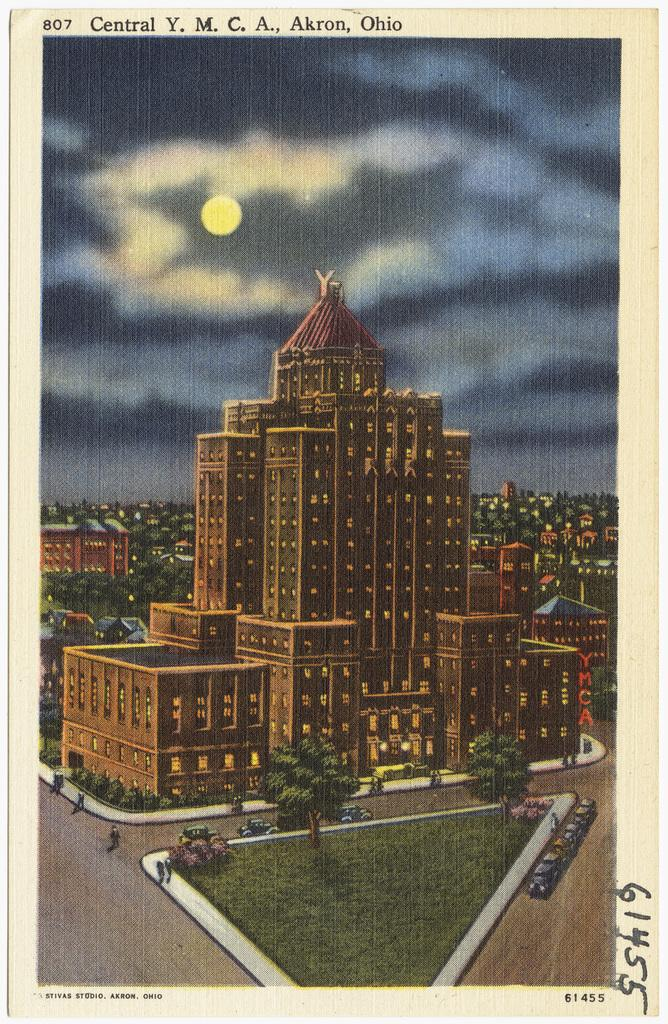What type of structures can be seen in the image? There are buildings in the image. What other natural elements are present in the image? There are trees in the image. What is happening on the road in the image? There are vehicles and people on the road in the image. What can be seen in the sky in the image? The moon is visible in the sky, and there are clouds as well. What type of fuel is being used by the trees in the image? There is no mention of trees using fuel in the image. Is there a harbor visible in the image? There is no harbor present in the image. 